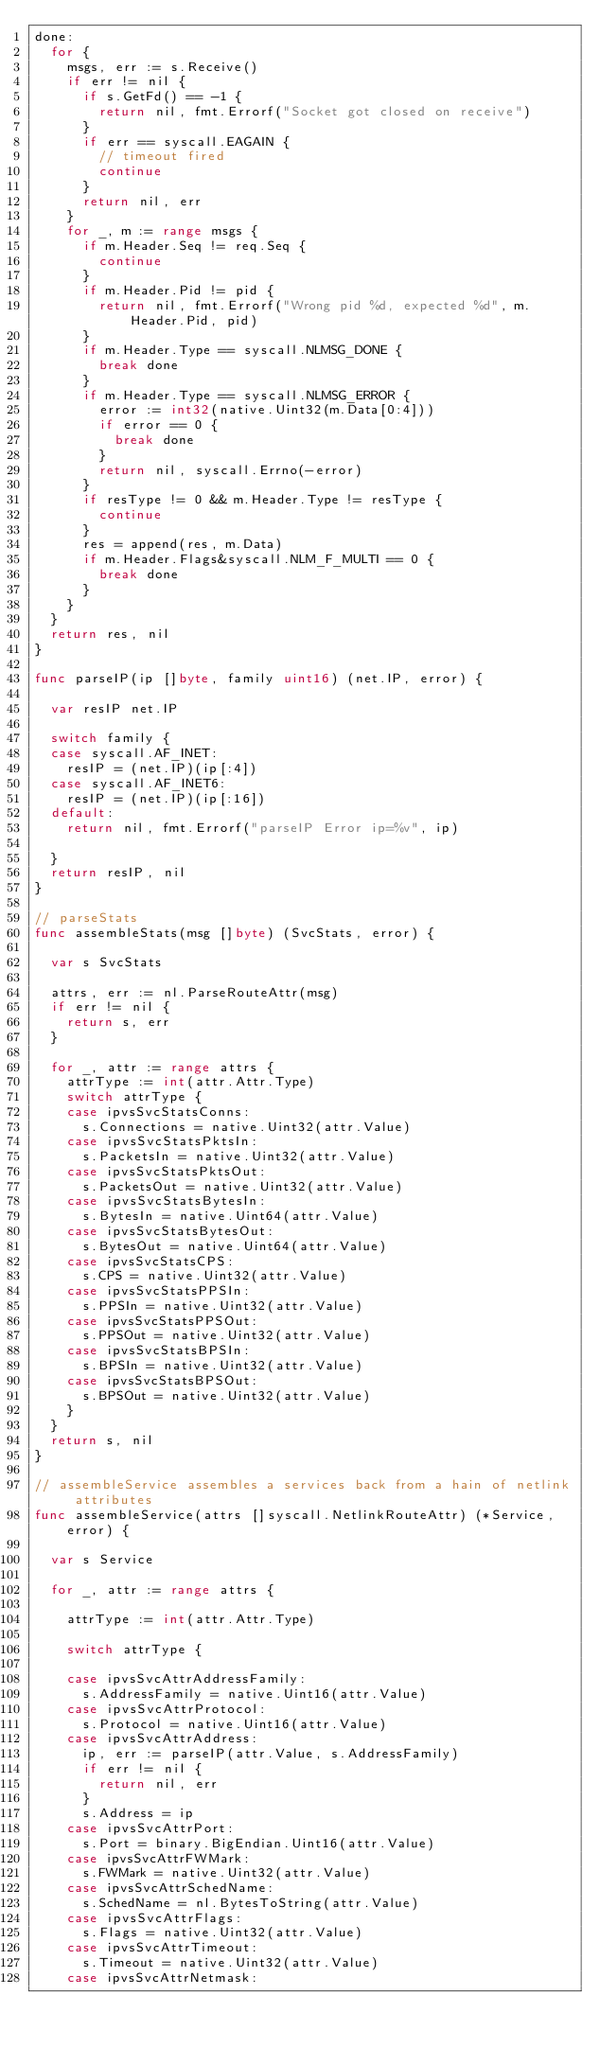Convert code to text. <code><loc_0><loc_0><loc_500><loc_500><_Go_>done:
	for {
		msgs, err := s.Receive()
		if err != nil {
			if s.GetFd() == -1 {
				return nil, fmt.Errorf("Socket got closed on receive")
			}
			if err == syscall.EAGAIN {
				// timeout fired
				continue
			}
			return nil, err
		}
		for _, m := range msgs {
			if m.Header.Seq != req.Seq {
				continue
			}
			if m.Header.Pid != pid {
				return nil, fmt.Errorf("Wrong pid %d, expected %d", m.Header.Pid, pid)
			}
			if m.Header.Type == syscall.NLMSG_DONE {
				break done
			}
			if m.Header.Type == syscall.NLMSG_ERROR {
				error := int32(native.Uint32(m.Data[0:4]))
				if error == 0 {
					break done
				}
				return nil, syscall.Errno(-error)
			}
			if resType != 0 && m.Header.Type != resType {
				continue
			}
			res = append(res, m.Data)
			if m.Header.Flags&syscall.NLM_F_MULTI == 0 {
				break done
			}
		}
	}
	return res, nil
}

func parseIP(ip []byte, family uint16) (net.IP, error) {

	var resIP net.IP

	switch family {
	case syscall.AF_INET:
		resIP = (net.IP)(ip[:4])
	case syscall.AF_INET6:
		resIP = (net.IP)(ip[:16])
	default:
		return nil, fmt.Errorf("parseIP Error ip=%v", ip)

	}
	return resIP, nil
}

// parseStats
func assembleStats(msg []byte) (SvcStats, error) {

	var s SvcStats

	attrs, err := nl.ParseRouteAttr(msg)
	if err != nil {
		return s, err
	}

	for _, attr := range attrs {
		attrType := int(attr.Attr.Type)
		switch attrType {
		case ipvsSvcStatsConns:
			s.Connections = native.Uint32(attr.Value)
		case ipvsSvcStatsPktsIn:
			s.PacketsIn = native.Uint32(attr.Value)
		case ipvsSvcStatsPktsOut:
			s.PacketsOut = native.Uint32(attr.Value)
		case ipvsSvcStatsBytesIn:
			s.BytesIn = native.Uint64(attr.Value)
		case ipvsSvcStatsBytesOut:
			s.BytesOut = native.Uint64(attr.Value)
		case ipvsSvcStatsCPS:
			s.CPS = native.Uint32(attr.Value)
		case ipvsSvcStatsPPSIn:
			s.PPSIn = native.Uint32(attr.Value)
		case ipvsSvcStatsPPSOut:
			s.PPSOut = native.Uint32(attr.Value)
		case ipvsSvcStatsBPSIn:
			s.BPSIn = native.Uint32(attr.Value)
		case ipvsSvcStatsBPSOut:
			s.BPSOut = native.Uint32(attr.Value)
		}
	}
	return s, nil
}

// assembleService assembles a services back from a hain of netlink attributes
func assembleService(attrs []syscall.NetlinkRouteAttr) (*Service, error) {

	var s Service

	for _, attr := range attrs {

		attrType := int(attr.Attr.Type)

		switch attrType {

		case ipvsSvcAttrAddressFamily:
			s.AddressFamily = native.Uint16(attr.Value)
		case ipvsSvcAttrProtocol:
			s.Protocol = native.Uint16(attr.Value)
		case ipvsSvcAttrAddress:
			ip, err := parseIP(attr.Value, s.AddressFamily)
			if err != nil {
				return nil, err
			}
			s.Address = ip
		case ipvsSvcAttrPort:
			s.Port = binary.BigEndian.Uint16(attr.Value)
		case ipvsSvcAttrFWMark:
			s.FWMark = native.Uint32(attr.Value)
		case ipvsSvcAttrSchedName:
			s.SchedName = nl.BytesToString(attr.Value)
		case ipvsSvcAttrFlags:
			s.Flags = native.Uint32(attr.Value)
		case ipvsSvcAttrTimeout:
			s.Timeout = native.Uint32(attr.Value)
		case ipvsSvcAttrNetmask:</code> 